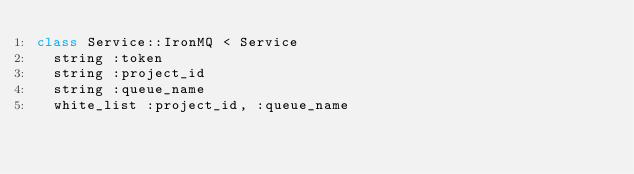<code> <loc_0><loc_0><loc_500><loc_500><_Ruby_>class Service::IronMQ < Service
  string :token
  string :project_id
  string :queue_name
  white_list :project_id, :queue_name
</code> 